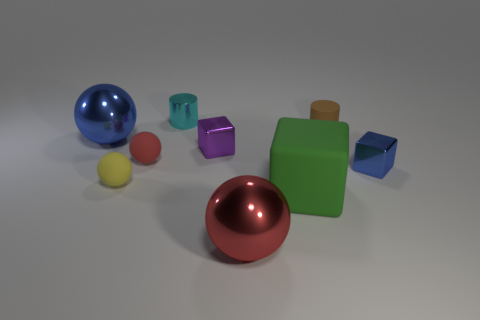Subtract all purple balls. Subtract all yellow cylinders. How many balls are left? 4 Add 1 small brown cylinders. How many objects exist? 10 Subtract all cylinders. How many objects are left? 7 Subtract all small purple spheres. Subtract all blue shiny objects. How many objects are left? 7 Add 7 small blocks. How many small blocks are left? 9 Add 3 cyan metallic cubes. How many cyan metallic cubes exist? 3 Subtract 0 brown balls. How many objects are left? 9 